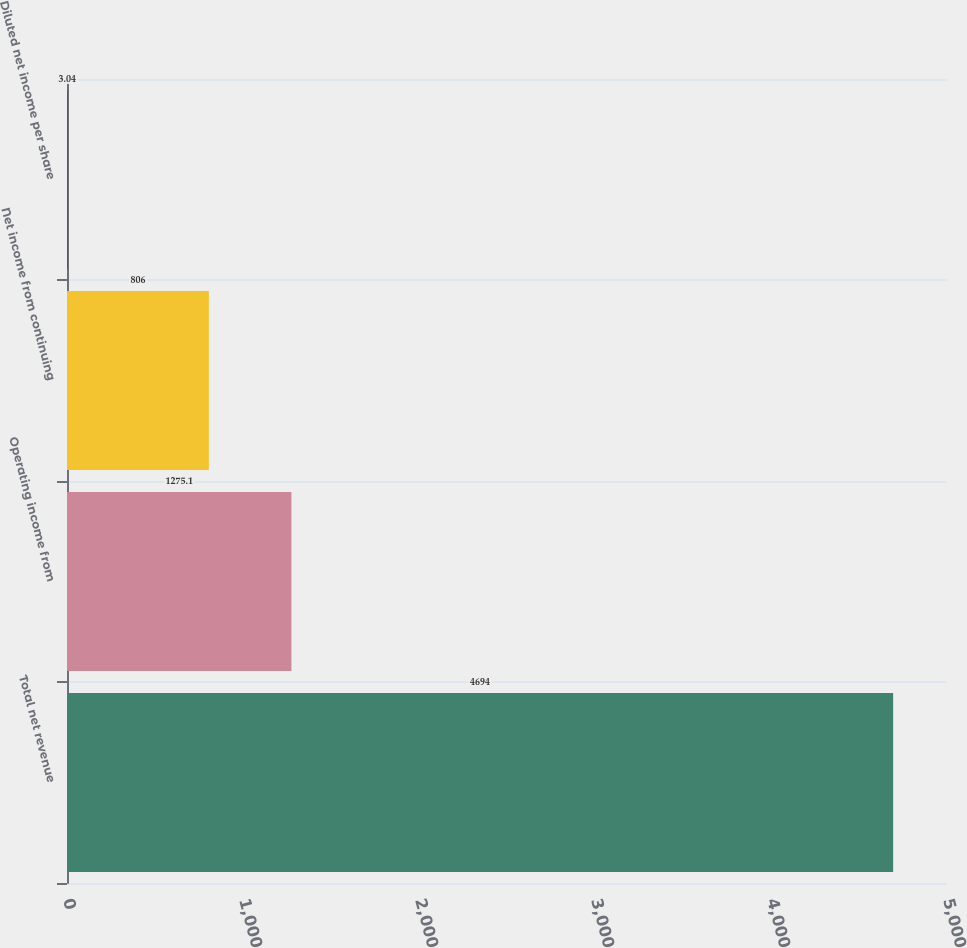Convert chart. <chart><loc_0><loc_0><loc_500><loc_500><bar_chart><fcel>Total net revenue<fcel>Operating income from<fcel>Net income from continuing<fcel>Diluted net income per share<nl><fcel>4694<fcel>1275.1<fcel>806<fcel>3.04<nl></chart> 